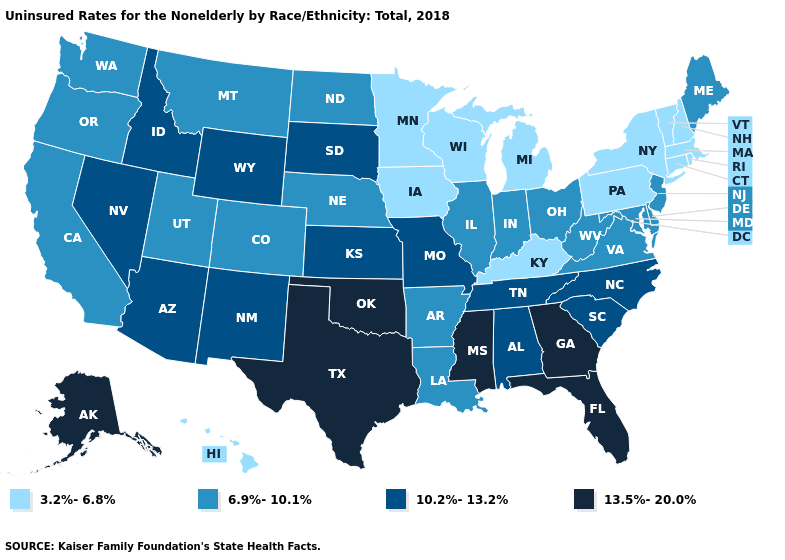Which states have the highest value in the USA?
Concise answer only. Alaska, Florida, Georgia, Mississippi, Oklahoma, Texas. Does Wisconsin have the lowest value in the USA?
Short answer required. Yes. Does Arizona have a lower value than Utah?
Concise answer only. No. Name the states that have a value in the range 3.2%-6.8%?
Concise answer only. Connecticut, Hawaii, Iowa, Kentucky, Massachusetts, Michigan, Minnesota, New Hampshire, New York, Pennsylvania, Rhode Island, Vermont, Wisconsin. Name the states that have a value in the range 13.5%-20.0%?
Keep it brief. Alaska, Florida, Georgia, Mississippi, Oklahoma, Texas. Which states hav the highest value in the West?
Concise answer only. Alaska. Name the states that have a value in the range 6.9%-10.1%?
Concise answer only. Arkansas, California, Colorado, Delaware, Illinois, Indiana, Louisiana, Maine, Maryland, Montana, Nebraska, New Jersey, North Dakota, Ohio, Oregon, Utah, Virginia, Washington, West Virginia. Among the states that border Kentucky , does Tennessee have the lowest value?
Short answer required. No. What is the value of Alaska?
Quick response, please. 13.5%-20.0%. Name the states that have a value in the range 3.2%-6.8%?
Concise answer only. Connecticut, Hawaii, Iowa, Kentucky, Massachusetts, Michigan, Minnesota, New Hampshire, New York, Pennsylvania, Rhode Island, Vermont, Wisconsin. Name the states that have a value in the range 6.9%-10.1%?
Give a very brief answer. Arkansas, California, Colorado, Delaware, Illinois, Indiana, Louisiana, Maine, Maryland, Montana, Nebraska, New Jersey, North Dakota, Ohio, Oregon, Utah, Virginia, Washington, West Virginia. Which states have the lowest value in the USA?
Keep it brief. Connecticut, Hawaii, Iowa, Kentucky, Massachusetts, Michigan, Minnesota, New Hampshire, New York, Pennsylvania, Rhode Island, Vermont, Wisconsin. Among the states that border Idaho , does Oregon have the highest value?
Write a very short answer. No. Which states have the highest value in the USA?
Be succinct. Alaska, Florida, Georgia, Mississippi, Oklahoma, Texas. What is the value of Iowa?
Keep it brief. 3.2%-6.8%. 